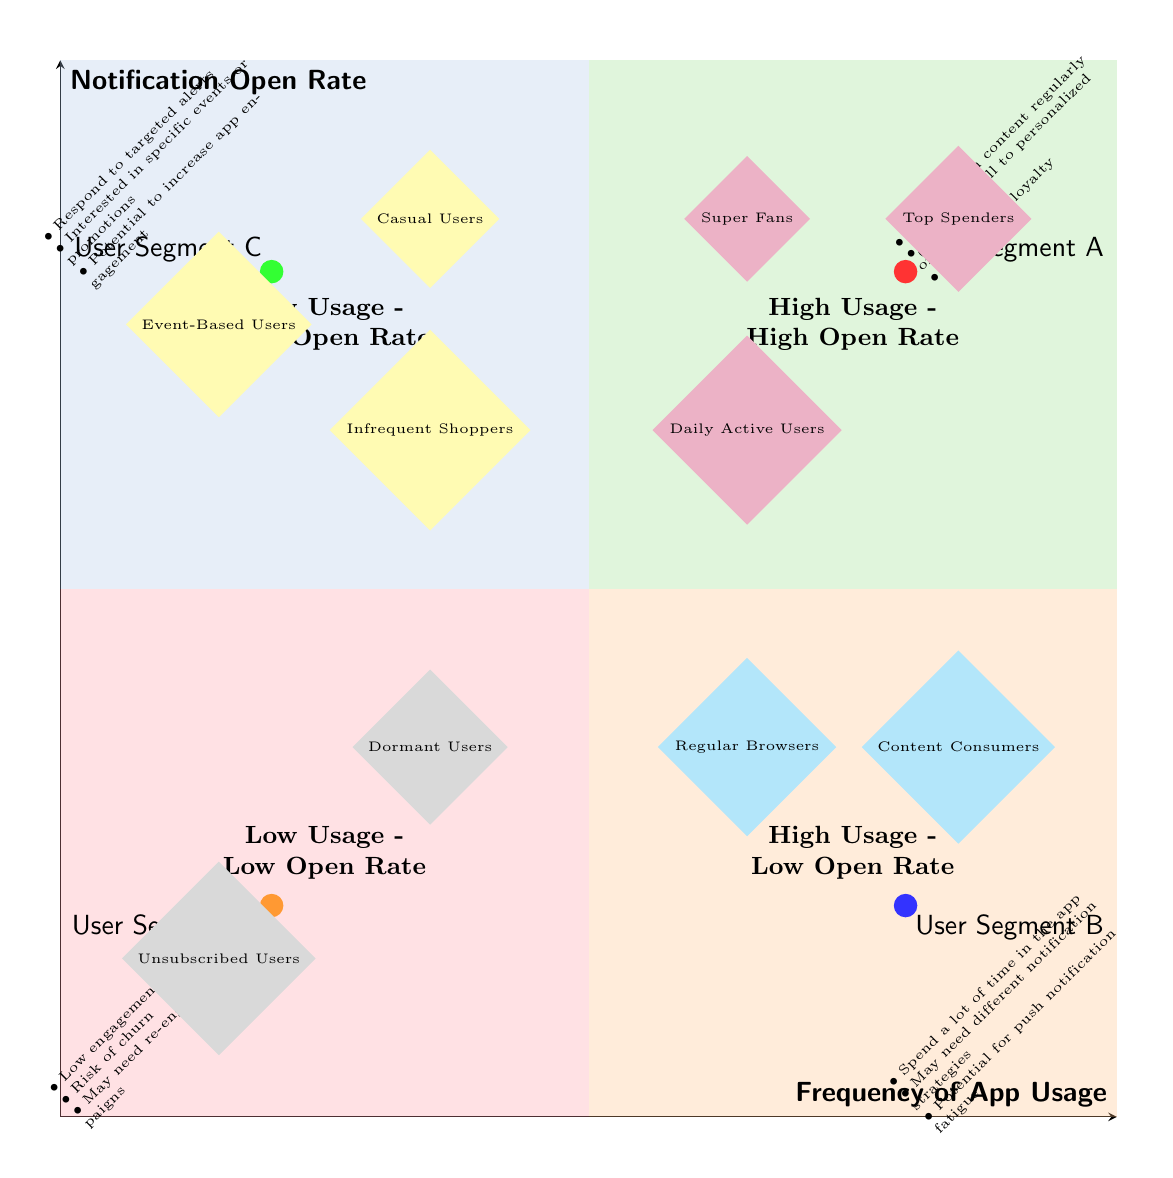What are the characteristics of users in the High Usage - High Open Rate quadrant? This quadrant includes users engaging with content regularly, responding well to personalized offers, and demonstrating high brand loyalty.
Answer: Engage with content regularly, respond well to personalized offers, high brand loyalty How many user segments are in the Low Usage - Low Open Rate quadrant? There are two user segments identified in this quadrant: Dormant Users and Unsubscribed Users.
Answer: 2 Which user segment has a high frequency of app usage but a low notification open rate? User Segment B is characterized as having a high app usage frequency and a low notification open rate, indicating different engagement behavior.
Answer: User Segment B What is a potential strategy for users in the High Usage - Low Open Rate quadrant? Users here may need different notification strategies to better engage them and increase their response rates to notifications.
Answer: Different notification strategies Which quadrant includes Infrequent Shoppers? Infrequent Shoppers are classified in the Low Usage - High Open Rate quadrant, indicating that they may not use the app frequently but open notifications when received.
Answer: Low Usage - High Open Rate In the diagram, what color represents the Low Usage - Low Open Rate quadrant? The Low Usage - Low Open Rate quadrant is represented by an orange color in the diagram, indicating a low engagement level among users.
Answer: Orange What is the description of the High Usage - Low Open Rate quadrant? This quadrant is described as users who frequently use the app but do not often open push notifications, indicating different levels of engagement with content.
Answer: Users frequently use the app but do not open push notifications often How many characteristics are listed for the Low Usage - High Open Rate quadrant? Three characteristics are associated with the Low Usage - High Open Rate quadrant, focusing on targeted alerts and promotional interests.
Answer: 3 